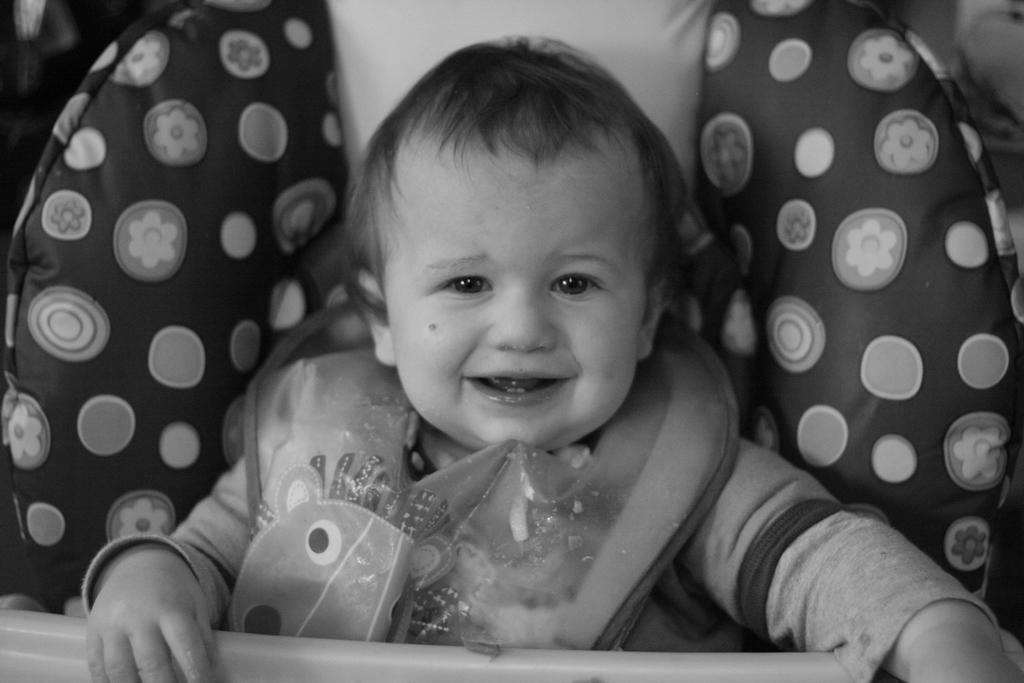Describe this image in one or two sentences. This is a black and white image. In this image there is a baby sitting in a baby chair. He is smiling. 